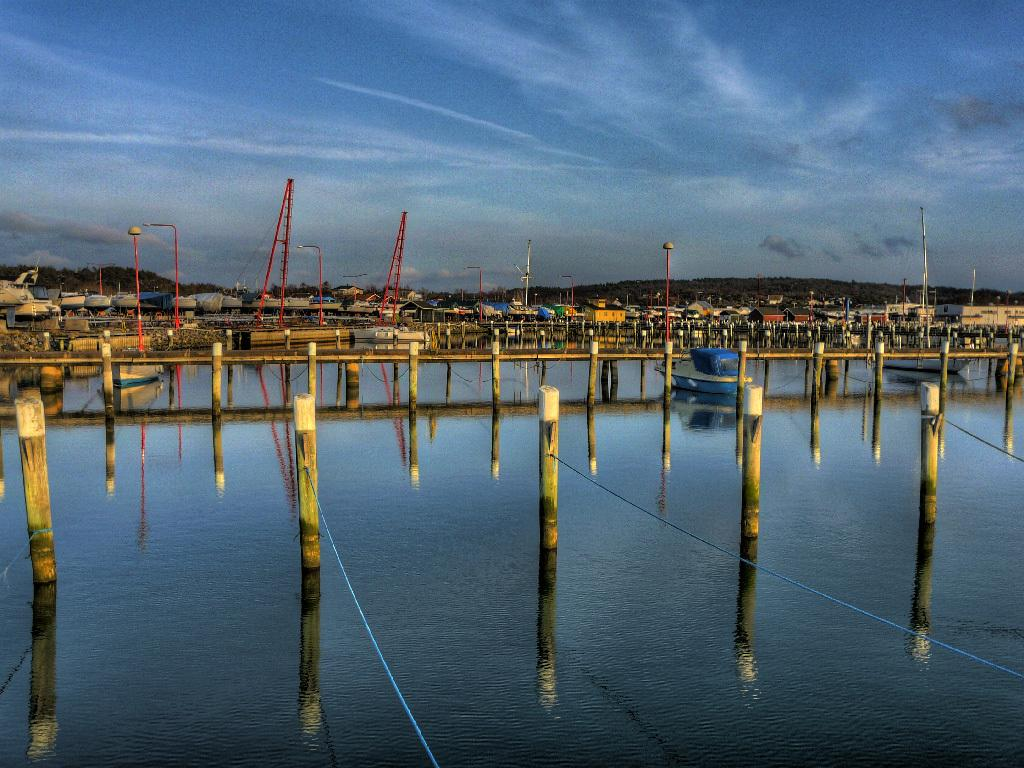What can be seen at the bottom of the image? There is water visible at the bottom of the image. What is visible at the top of the image? The sky is visible at the top of the image. Where is the garden located in the image? There is no garden present in the image. How many bikes can be seen in the image? There are no bikes present in the image. 